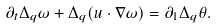<formula> <loc_0><loc_0><loc_500><loc_500>\partial _ { t } \Delta _ { q } \omega + \Delta _ { q } ( u \cdot \nabla \omega ) = \partial _ { 1 } \Delta _ { q } \theta .</formula> 